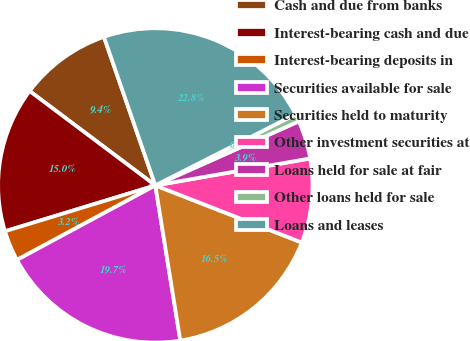<chart> <loc_0><loc_0><loc_500><loc_500><pie_chart><fcel>Cash and due from banks<fcel>Interest-bearing cash and due<fcel>Interest-bearing deposits in<fcel>Securities available for sale<fcel>Securities held to maturity<fcel>Other investment securities at<fcel>Loans held for sale at fair<fcel>Other loans held for sale<fcel>Loans and leases<nl><fcel>9.45%<fcel>14.96%<fcel>3.15%<fcel>19.68%<fcel>16.54%<fcel>8.66%<fcel>3.94%<fcel>0.79%<fcel>22.83%<nl></chart> 